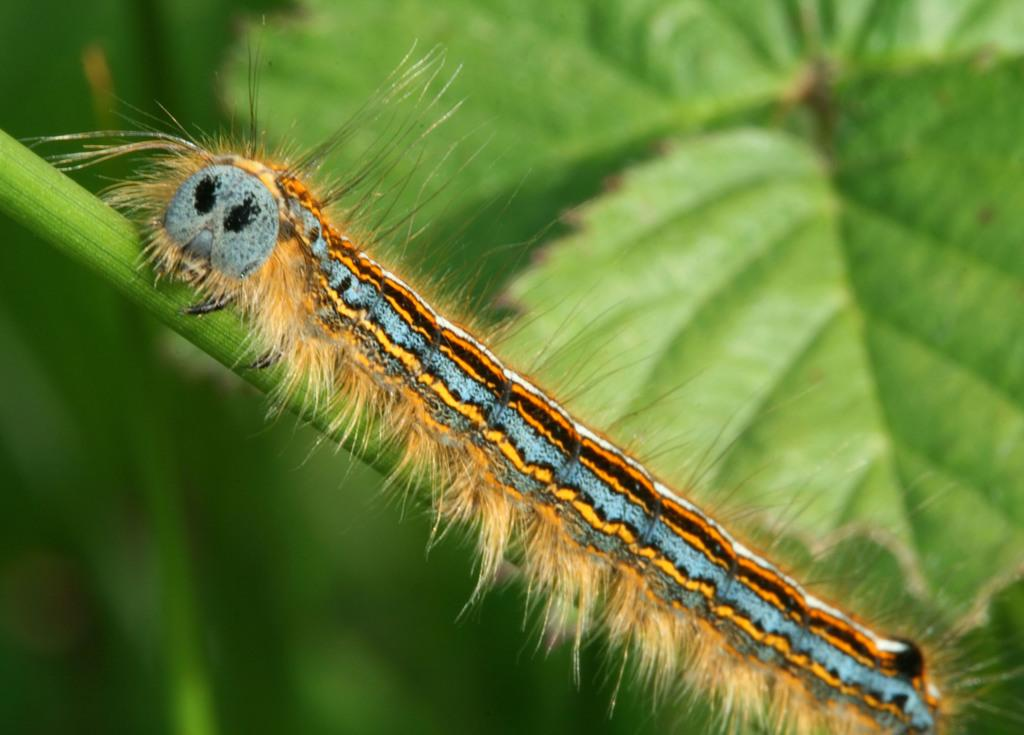What type of insect is present in the image? There is a lackey moth caterpillar in the image. Where is the caterpillar located? The caterpillar is on a branch. What can be seen behind the caterpillar in the image? There are leaves behind the caterpillar in the image. How many chickens are visible in the image? There are no chickens present in the image; it features a lackey moth caterpillar on a branch with leaves in the background. What type of cattle can be seen grazing in the image? There are no cattle present in the image. 